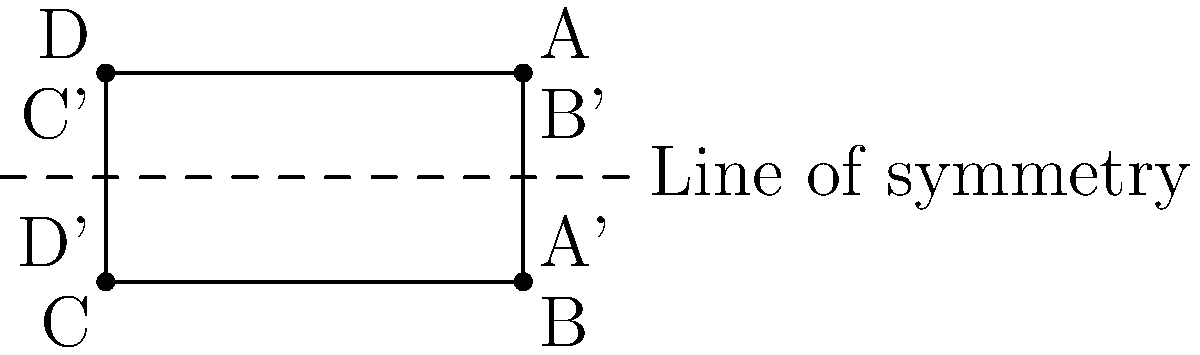A protest sign shaped like a rectangle ABCD is reflected across a horizontal line of symmetry. If the coordinates of point A are (2,1), what are the coordinates of its reflection, point A'? To solve this problem, we'll follow these steps:

1) Recognize that the line of symmetry is the x-axis (y = 0).

2) Recall the rule for reflecting a point (x, y) across the x-axis:
   The reflected point will have coordinates (x, -y).

3) We're given that point A has coordinates (2, 1).

4) Apply the reflection rule to point A:
   x-coordinate remains the same: 2
   y-coordinate changes sign: -1

5) Therefore, the coordinates of A' are (2, -1).

This reflection demonstrates how the shape and position of protest signs might be affected when viewed from different perspectives, which could be relevant in cases involving visual elements of free speech.
Answer: (2, -1) 